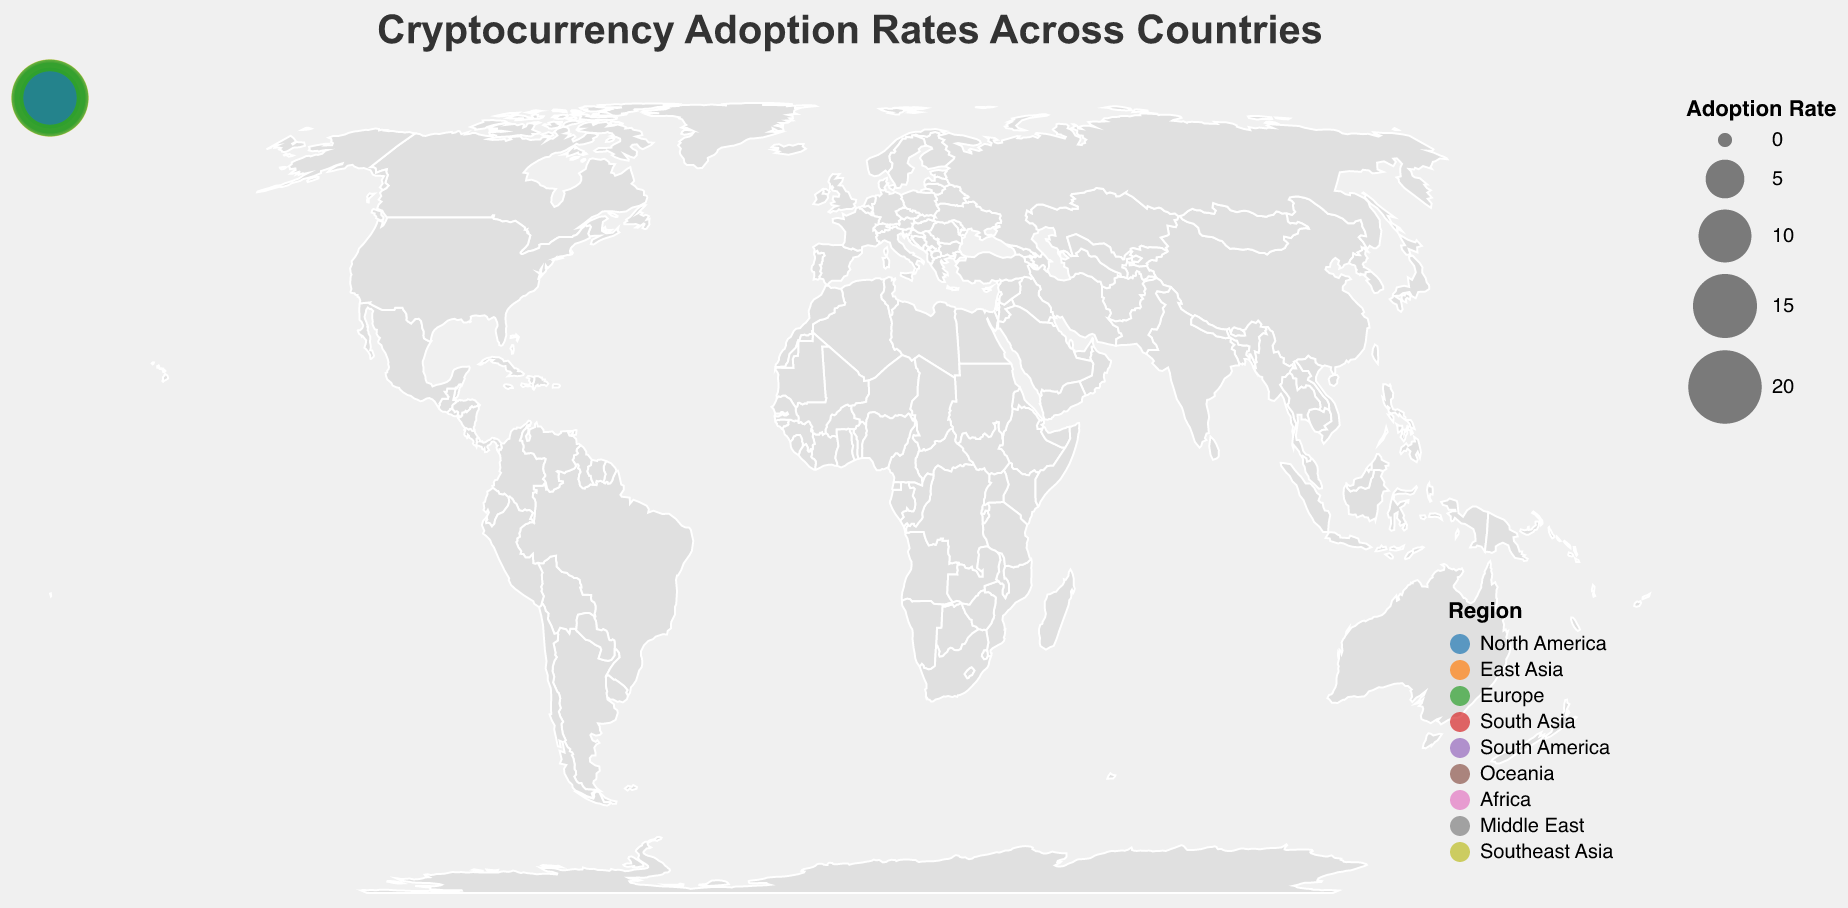Which country has the highest cryptocurrency adoption rate? By observing the plot, the country with the largest circle indicates the highest adoption rate. The biggest circle is located in Singapore.
Answer: Singapore What is the adoption rate for Canada? Find the circle located in Canada and refer to its size as it is encoded to represent the adoption rate. Canada has an adoption rate of 19.8%.
Answer: 19.8% Which region has the most countries in the top five for adoption rates? Identify the top five largest circles representing the highest adoption rates. Note their corresponding regions. Singapore (Southeast Asia), Switzerland (Europe), United States (North America), Canada (North America), Netherlands (Europe).
Answer: North America and Europe What is the average adoption rate for countries in the East Asia region? Locate the circles for China (13.8), Japan (11.5), and South Korea (15.7) and calculate the average by summing these values and dividing by three. (13.8 + 11.5 + 15.7) / 3 = 13.67.
Answer: 13.67 How does the adoption rate in the United States compare to that in the United Kingdom? Compare the size of the circles representing the United States (20.1) and the United Kingdom (18.3). The United States has a higher adoption rate.
Answer: The United States has a higher adoption rate Which country in Europe has the lowest cryptocurrency adoption rate? Identify the smallest circle within Europe. Russia has an adoption rate of 11.8%, and there are no countries in Europe with a lower rate.
Answer: Russia What is the total adoption rate for North America? Sum the adoption rates of the countries located in North America: United States (20.1), Canada (19.8), and Mexico (10.2). 20.1 + 19.8 + 10.2 = 50.1.
Answer: 50.1 What is the difference in adoption rates between Nigeria and South Africa? Calculate the difference by subtracting South Africa's rate (8.9) from Nigeria's rate (10.7). 10.7 - 8.9 = 1.8.
Answer: 1.8 Which country in the Middle East has been included in the plot, and what is its adoption rate? Check the circles labeled within the Middle East region. The country is United Arab Emirates with an adoption rate of 14.6%.
Answer: United Arab Emirates, 14.6% What can be inferred about the overall adoption rate trends in Oceania based on the plot? Oceania is represented by Australia, with an adoption rate of 17.5%, which suggests a relatively high adoption rate compared to the global data.
Answer: High adoption rate in Oceania 